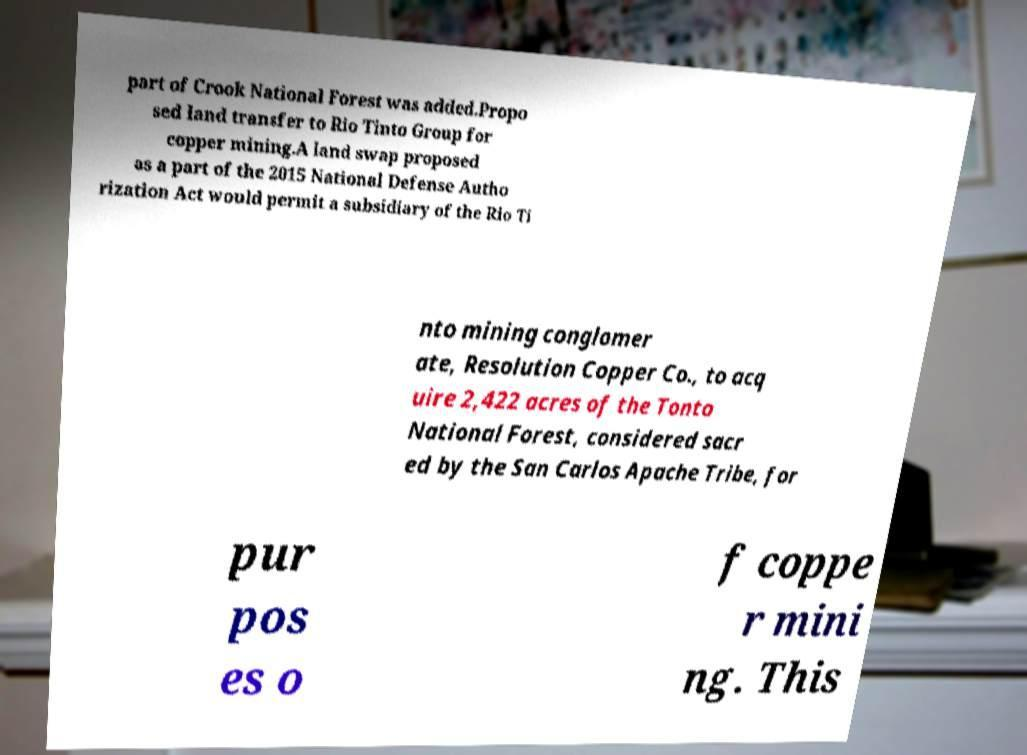Could you assist in decoding the text presented in this image and type it out clearly? part of Crook National Forest was added.Propo sed land transfer to Rio Tinto Group for copper mining.A land swap proposed as a part of the 2015 National Defense Autho rization Act would permit a subsidiary of the Rio Ti nto mining conglomer ate, Resolution Copper Co., to acq uire 2,422 acres of the Tonto National Forest, considered sacr ed by the San Carlos Apache Tribe, for pur pos es o f coppe r mini ng. This 